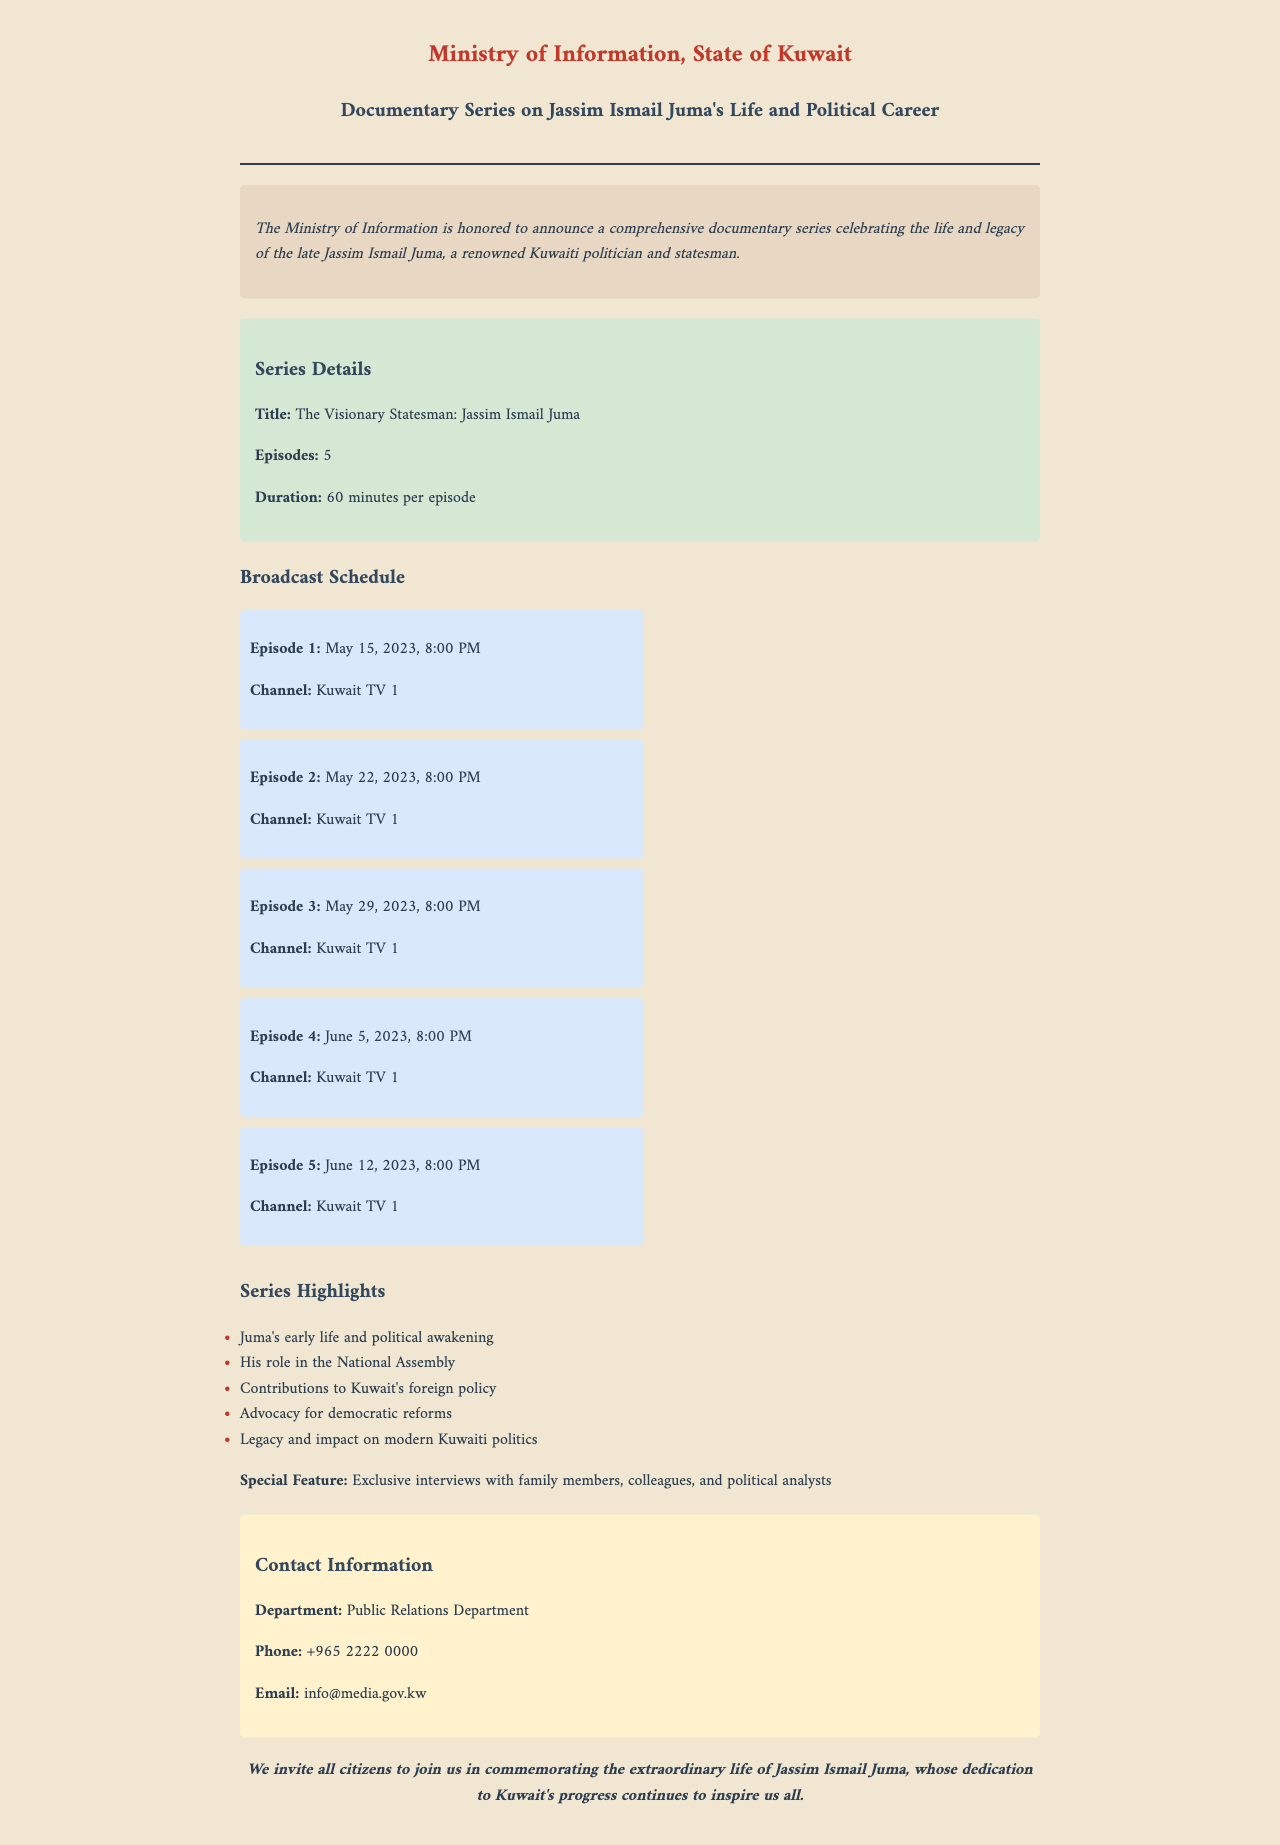what is the title of the documentary series? The title of the documentary series is stated clearly in the document section dedicated to series details.
Answer: The Visionary Statesman: Jassim Ismail Juma how many episodes does the series have? The number of episodes is provided in the series details section of the document.
Answer: 5 when is the first episode scheduled to air? The broadcast schedule includes specific dates for each episode, with the first episode airing on May 15, 2023.
Answer: May 15, 2023 what channel will the documentary be broadcasted on? The channel is mentioned repeatedly in the broadcast schedule for each episode.
Answer: Kuwait TV 1 what is the duration of each episode? The duration is included in the series details section, indicating how long each episode will be.
Answer: 60 minutes which episode covers Juma's contributions to the National Assembly? Understanding the highlights of the series requires reasoning about the content of the documentary episodes.
Answer: All episodes cover various aspects, but the specific details are not provided in the schedule who is the contact person for this documentary? The contact information section of the document specifies which department to reach out to for inquiries related to the series.
Answer: Public Relations Department what is the phone number for inquiries? The document provides a specific phone number for the Public Relations Department.
Answer: +965 2222 0000 